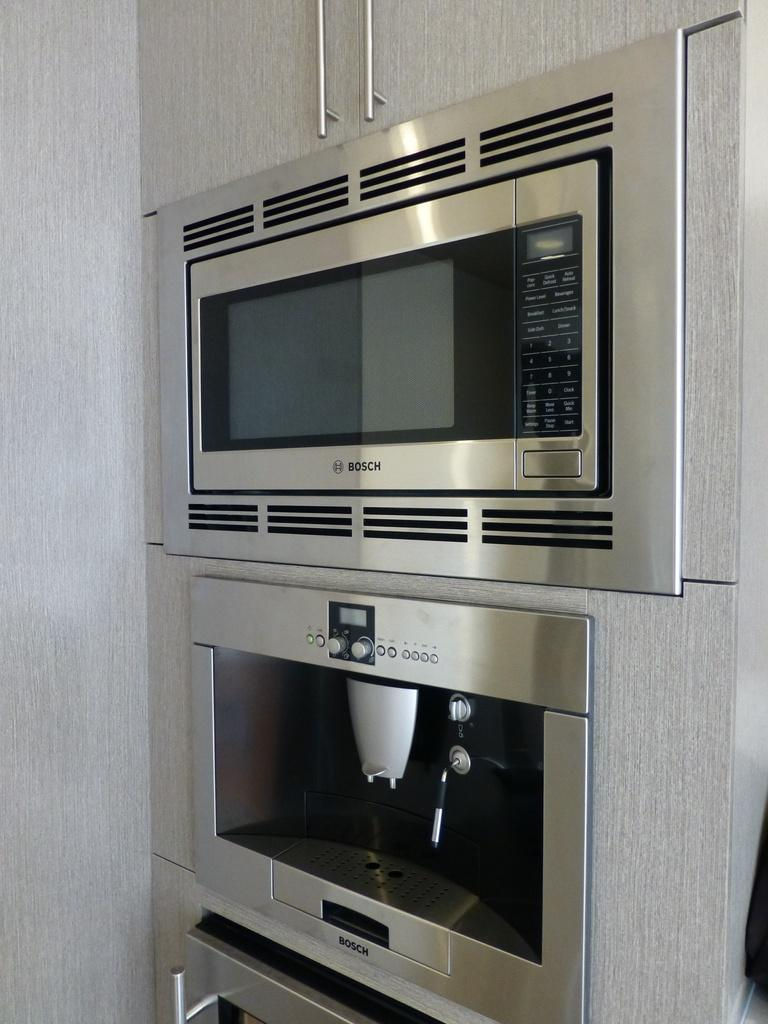What type of furniture is present in the image? There is a cupboard in the image. What appliance can be seen inside the cupboard? There is a microwave oven placed in the cupboard. Can you describe any other objects in the image? There appears to be a cloth at the side of the image. What type of haircut is the tent getting in the image? There is no tent or haircut present in the image. 